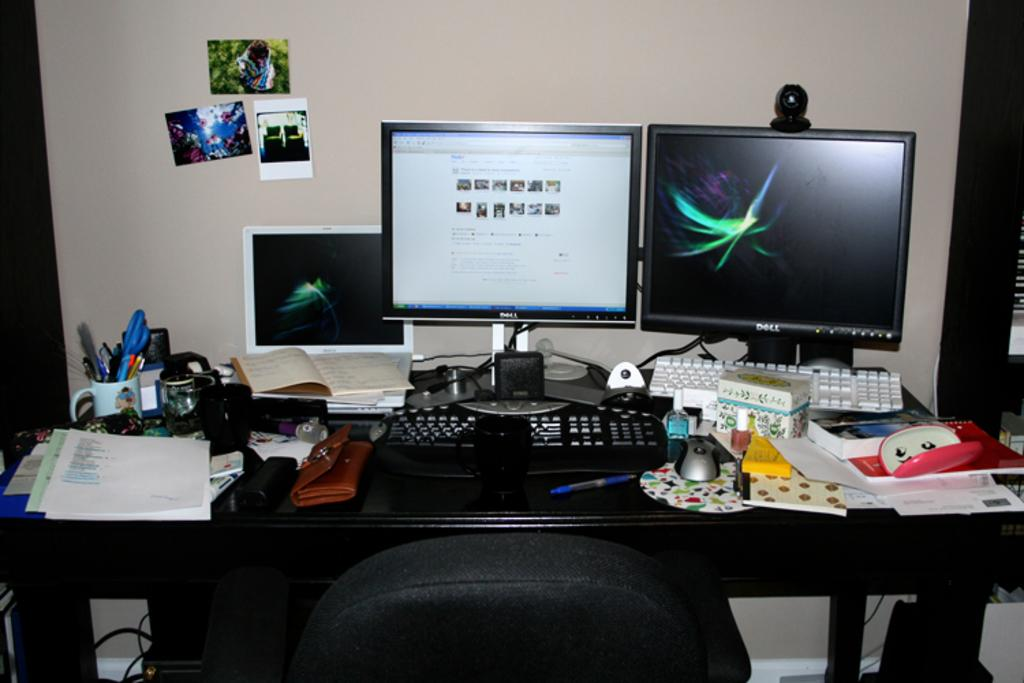What type of furniture is present in the image? There is a chair in the image. What object related to writing or drawing can be seen in the image? There are pens in the image. What electronic devices are visible in the image? There is a monitor, a keyboard, and a mouse in the image. What items are on the table in the image? There is a paper, a cup, and boxes on the table in the image. Can you hear the guitar playing in the background of the image? There is no guitar present in the image, so it is not possible to hear it playing. Is there a payment system visible in the image? There is no payment system present in the image. 